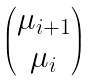Convert formula to latex. <formula><loc_0><loc_0><loc_500><loc_500>\begin{pmatrix} \mu _ { i + 1 } \\ \mu _ { i } \end{pmatrix}</formula> 